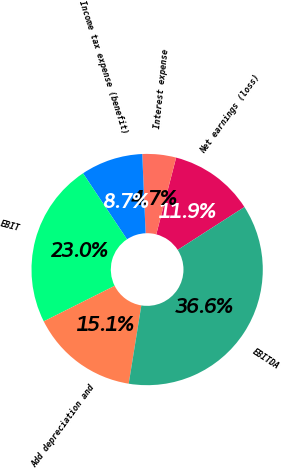Convert chart to OTSL. <chart><loc_0><loc_0><loc_500><loc_500><pie_chart><fcel>Net earnings (loss)<fcel>Interest expense<fcel>Income tax expense (benefit)<fcel>EBIT<fcel>Add depreciation and<fcel>EBITDA<nl><fcel>11.87%<fcel>4.71%<fcel>8.68%<fcel>23.04%<fcel>15.06%<fcel>36.64%<nl></chart> 